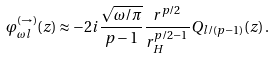Convert formula to latex. <formula><loc_0><loc_0><loc_500><loc_500>\varphi ^ { ( \rightarrow ) } _ { \omega l } ( z ) \approx - 2 i \frac { \sqrt { \omega / \pi } } { p - 1 } \frac { r ^ { p / 2 } } { r _ { H } ^ { p / 2 - 1 } } Q _ { { l } / { ( p - 1 ) } } ( z ) \, .</formula> 